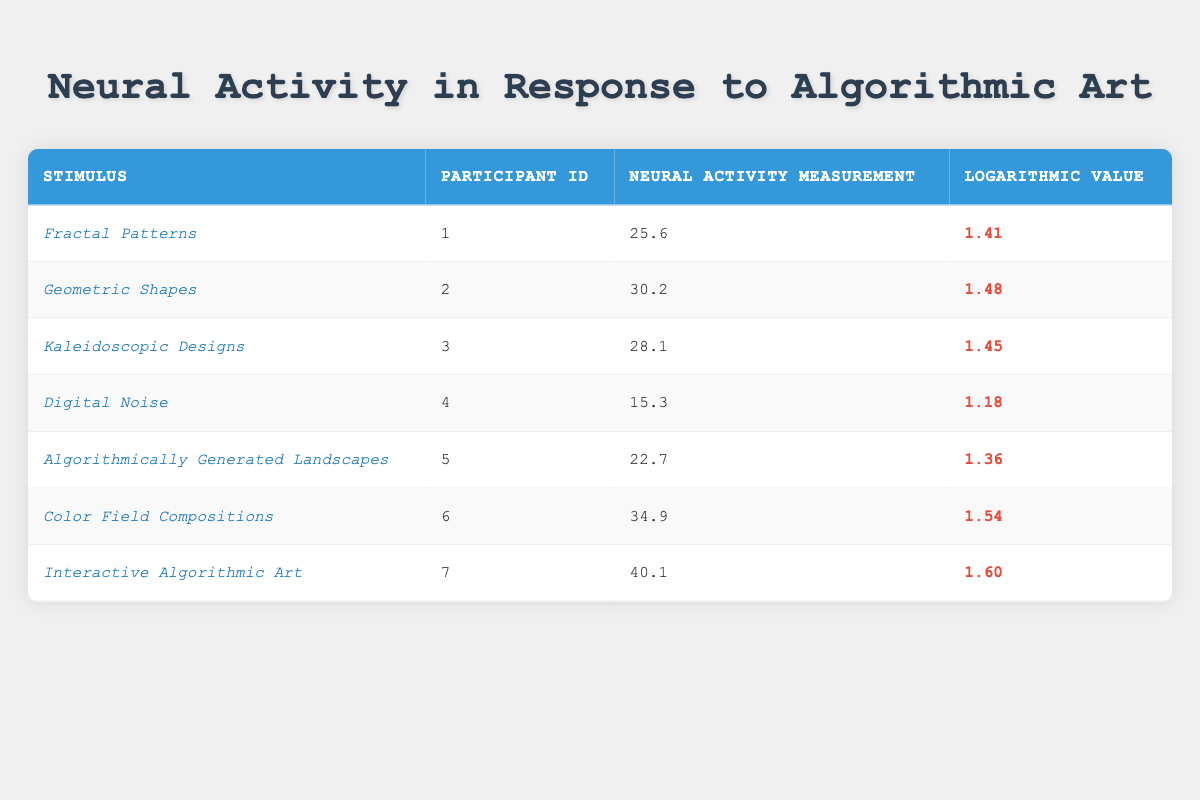What is the Neural Activity Measurement for "Color Field Compositions"? From the table, I can directly find the value in the row corresponding to "Color Field Compositions", which shows a Neural Activity Measurement of 34.9.
Answer: 34.9 Which stimulus has the highest Neural Activity Measurement? Looking at the Neural Activity Measurements for all stimuli, "Interactive Algorithmic Art", with a measurement of 40.1, is the highest.
Answer: Interactive Algorithmic Art What is the difference between the Neural Activity Measurements of "Fractal Patterns" and "Digital Noise"? The measurement for "Fractal Patterns" is 25.6 and for "Digital Noise" is 15.3. The difference is calculated by subtracting: 25.6 - 15.3 = 10.3.
Answer: 10.3 Is the Logarithmic Value for "Kaleidoscopic Designs" higher than 1.5? The Logarithmic Value for "Kaleidoscopic Designs" is 1.45, which is less than 1.5. Therefore, the answer is no.
Answer: No What is the average Neural Activity Measurement across all stimuli? To find the average, sum all the Neural Activity Measurements: (25.6 + 30.2 + 28.1 + 15.3 + 22.7 + 34.9 + 40.1) = 195.9. There are 7 measurements, so: 195.9 / 7 = 27.4.
Answer: 27.4 How many stimuli have a Logarithmic Value greater than 1.4? We review the Logarithmic Values: Fractal Patterns (1.41), Geometric Shapes (1.48), Kaleidoscopic Designs (1.45), Digital Noise (1.18), Algorithmically Generated Landscapes (1.36), Color Field Compositions (1.54), Interactive Algorithmic Art (1.60). The values greater than 1.4 are: Geometric Shapes, Kaleidoscopic Designs, Color Field Compositions, and Interactive Algorithmic Art, totaling 4 stimuli.
Answer: 4 What is the sum of the Neural Activity Measurements for "Digital Noise" and "Algorithmically Generated Landscapes"? For "Digital Noise", the measurement is 15.3 and for "Algorithmically Generated Landscapes", it is 22.7. Summing these gives: 15.3 + 22.7 = 38.0.
Answer: 38.0 Is there a participant that responded to "Interactive Algorithmic Art"? Looking at the table, Participant ID 7 corresponds to "Interactive Algorithmic Art." Hence, the answer is yes.
Answer: Yes 